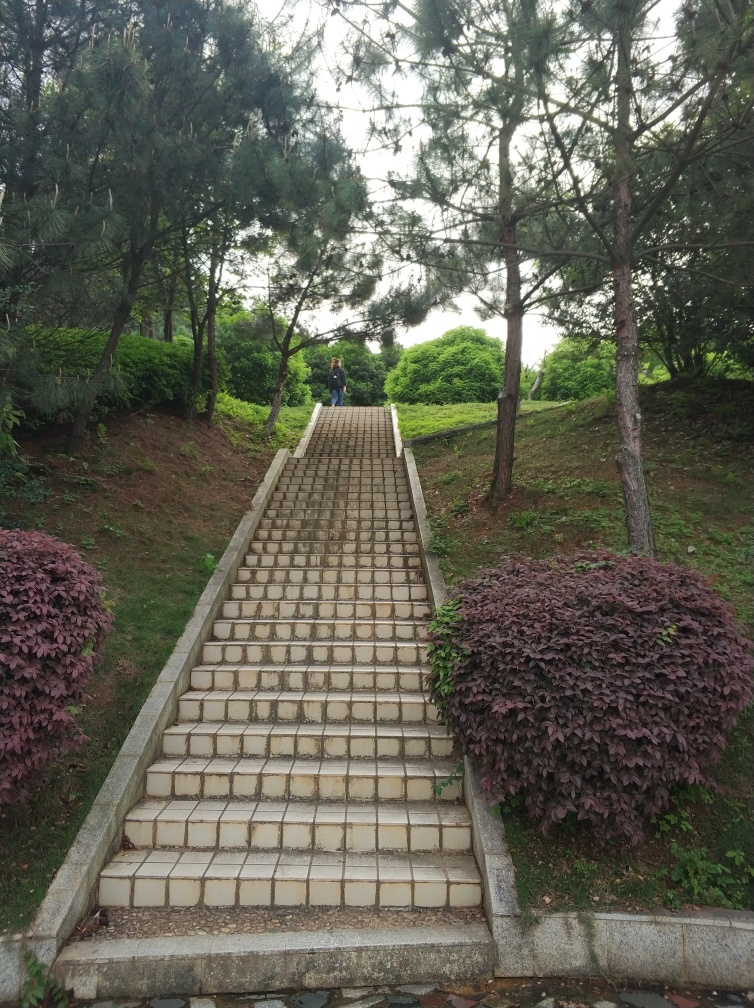What might the weather or climate be like in this area based on the vegetation and sky? Based on the lush, green vegetation, including what appear to be conifers, and the overcast sky, this area likely experiences a temperate climate with sufficient rainfall. The healthy state of the flora implies that this region receives adequate moisture and likely has mild to cool temperatures conducive to the growth of such plants. 